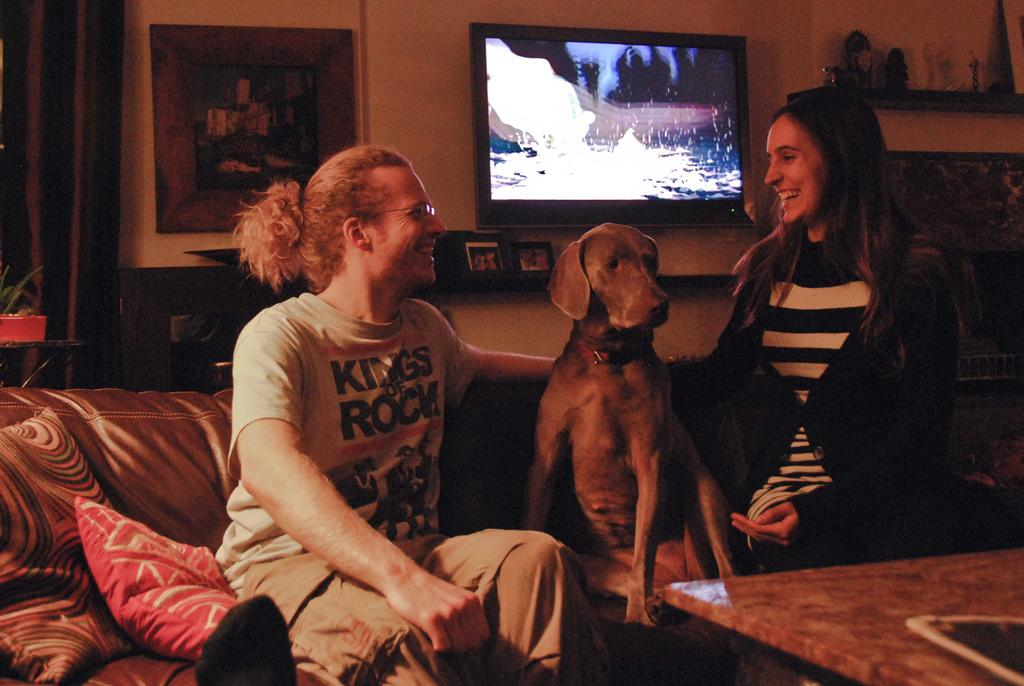What are the people in the image doing? The people in the image are sitting on a couch. What is located in the middle of the couch? There is a dog in the middle of the couch. What can be seen behind the people? There is a television behind the people. Can you describe any other objects or features in the image? There is a portrait present in the image. How many pies are being served on the beds in the image? There are no pies or beds present in the image; it features people sitting on a couch with a dog and a television in the background. 